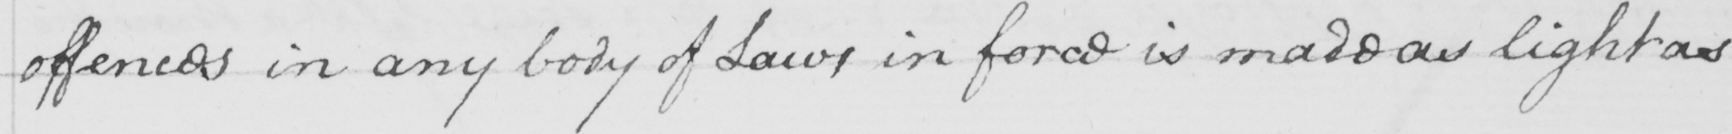Please provide the text content of this handwritten line. offences in any body of Laws in force is made as light as 